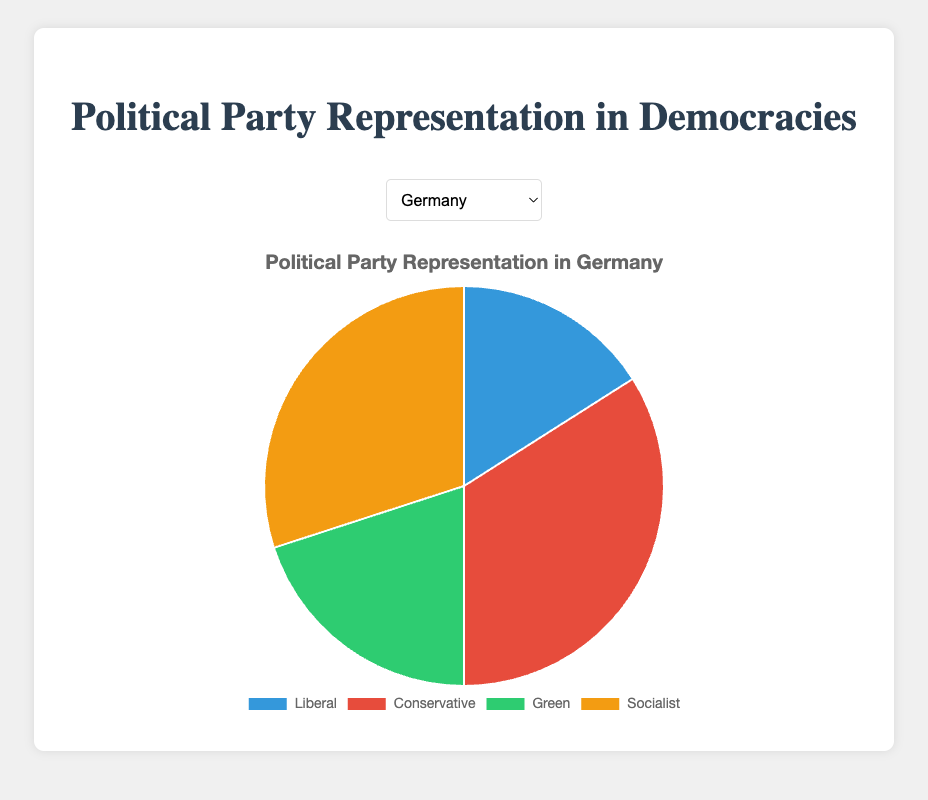Which country has the highest representation by the Conservative party? By examining the pie charts for the countries, the United Kingdom and Australia both have the highest Conservative representation at 40%.
Answer: United Kingdom, Australia Which party has the lowest representation in the United Kingdom? By looking at the pie chart for the UK, the Green party has the lowest representation at 5%.
Answer: Green In Germany, how many more seats does the Conservative party have than the Liberal party? The Conservative party has 34 seats and the Liberal party has 16 seats in Germany. The difference is 34 - 16 = 18 seats.
Answer: 18 In Canada, what is the combined representation of the Liberal and Socialist parties? The pie chart for Canada shows that the Liberal party has 35 seats and the Socialist party has 24 seats. The combined representation is 35 + 24 = 59 seats.
Answer: 59 Among the listed countries, which country has the highest representation of the Green party? The pie chart comparison reveals that Germany has the highest Green party representation at 20%.
Answer: Germany Which parties have an equal number of seats in Australia? The pie chart for Australia shows that the Liberal party has 25 seats and the Socialist party also has 20 seats.
Answer: None In the Netherlands, what percentage of representation is held by the Socialist party? The pie chart for the Netherlands shows that the Socialist party holds 32 seats out of the total (27 Liberal + 23 Conservative + 18 Green + 32 Socialist) = 100 seats. Thus, the percentage is (32 / 100) * 100 = 32%.
Answer: 32% Comparing Germany and Canada, which country has a higher representation by the Liberal party? By looking at the pie charts, Canada has 35 Liberal seats while Germany has 16 Liberal seats. Canada has a higher Liberal representation.
Answer: Canada In the United Kingdom, how does the representation of the Socialist party compare to the representation of the Conservative party? The pie chart for the UK shows the Socialist party has 45 seats and the Conservative party has 40 seats. The Socialist party has higher representation.
Answer: Socialist more What is the average representation of the Green party across all countries? The Green party representation in the countries is as follows: Germany: 20, UK: 5, Canada: 8, Australia: 15, Netherlands: 18. The average is (20 + 5 + 8 + 15 + 18) / 5 = 13.2.
Answer: 13.2 